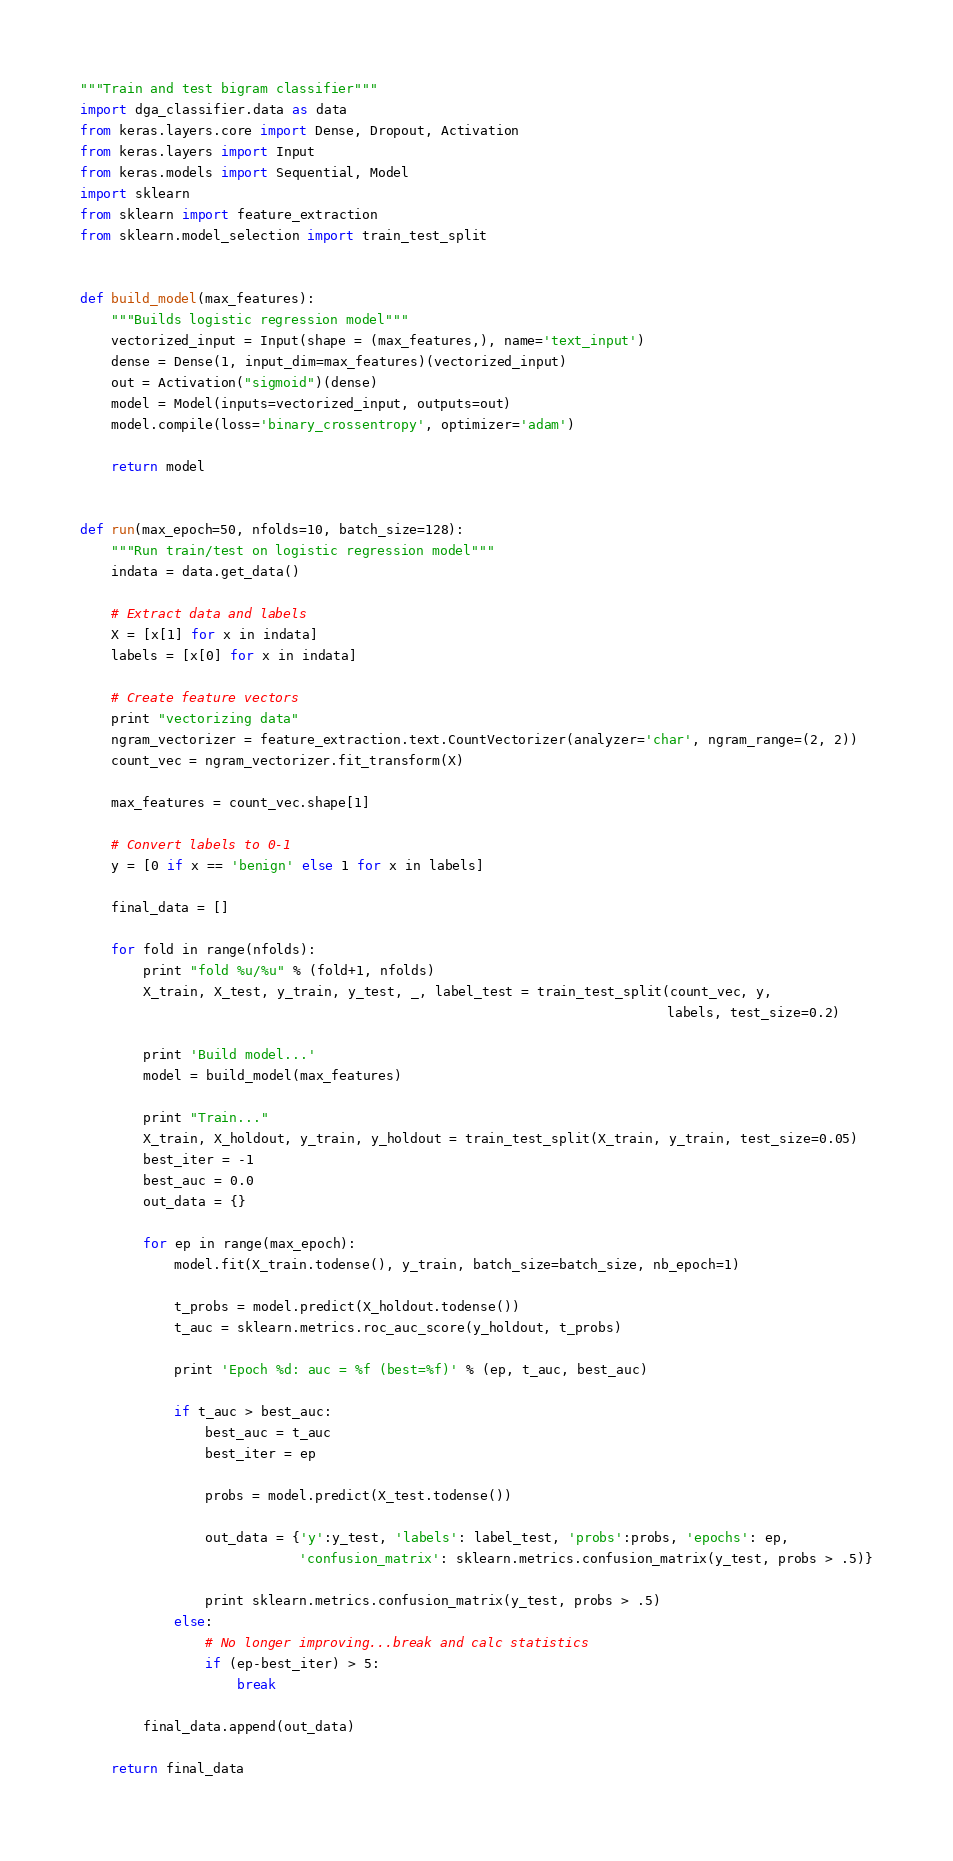<code> <loc_0><loc_0><loc_500><loc_500><_Python_>"""Train and test bigram classifier"""
import dga_classifier.data as data
from keras.layers.core import Dense, Dropout, Activation
from keras.layers import Input
from keras.models import Sequential, Model
import sklearn
from sklearn import feature_extraction
from sklearn.model_selection import train_test_split


def build_model(max_features):
    """Builds logistic regression model"""
    vectorized_input = Input(shape = (max_features,), name='text_input')
    dense = Dense(1, input_dim=max_features)(vectorized_input)
    out = Activation("sigmoid")(dense)
    model = Model(inputs=vectorized_input, outputs=out)
    model.compile(loss='binary_crossentropy', optimizer='adam')

    return model


def run(max_epoch=50, nfolds=10, batch_size=128):
    """Run train/test on logistic regression model"""
    indata = data.get_data()

    # Extract data and labels
    X = [x[1] for x in indata]
    labels = [x[0] for x in indata]

    # Create feature vectors
    print "vectorizing data"
    ngram_vectorizer = feature_extraction.text.CountVectorizer(analyzer='char', ngram_range=(2, 2))
    count_vec = ngram_vectorizer.fit_transform(X)

    max_features = count_vec.shape[1]

    # Convert labels to 0-1
    y = [0 if x == 'benign' else 1 for x in labels]

    final_data = []

    for fold in range(nfolds):
        print "fold %u/%u" % (fold+1, nfolds)
        X_train, X_test, y_train, y_test, _, label_test = train_test_split(count_vec, y,
                                                                           labels, test_size=0.2)

        print 'Build model...'
        model = build_model(max_features)

        print "Train..."
        X_train, X_holdout, y_train, y_holdout = train_test_split(X_train, y_train, test_size=0.05)
        best_iter = -1
        best_auc = 0.0
        out_data = {}

        for ep in range(max_epoch):
            model.fit(X_train.todense(), y_train, batch_size=batch_size, nb_epoch=1)

            t_probs = model.predict(X_holdout.todense())
            t_auc = sklearn.metrics.roc_auc_score(y_holdout, t_probs)

            print 'Epoch %d: auc = %f (best=%f)' % (ep, t_auc, best_auc)

            if t_auc > best_auc:
                best_auc = t_auc
                best_iter = ep

                probs = model.predict(X_test.todense())

                out_data = {'y':y_test, 'labels': label_test, 'probs':probs, 'epochs': ep,
                            'confusion_matrix': sklearn.metrics.confusion_matrix(y_test, probs > .5)}

                print sklearn.metrics.confusion_matrix(y_test, probs > .5)
            else:
                # No longer improving...break and calc statistics
                if (ep-best_iter) > 5:
                    break

        final_data.append(out_data)

    return final_data
</code> 